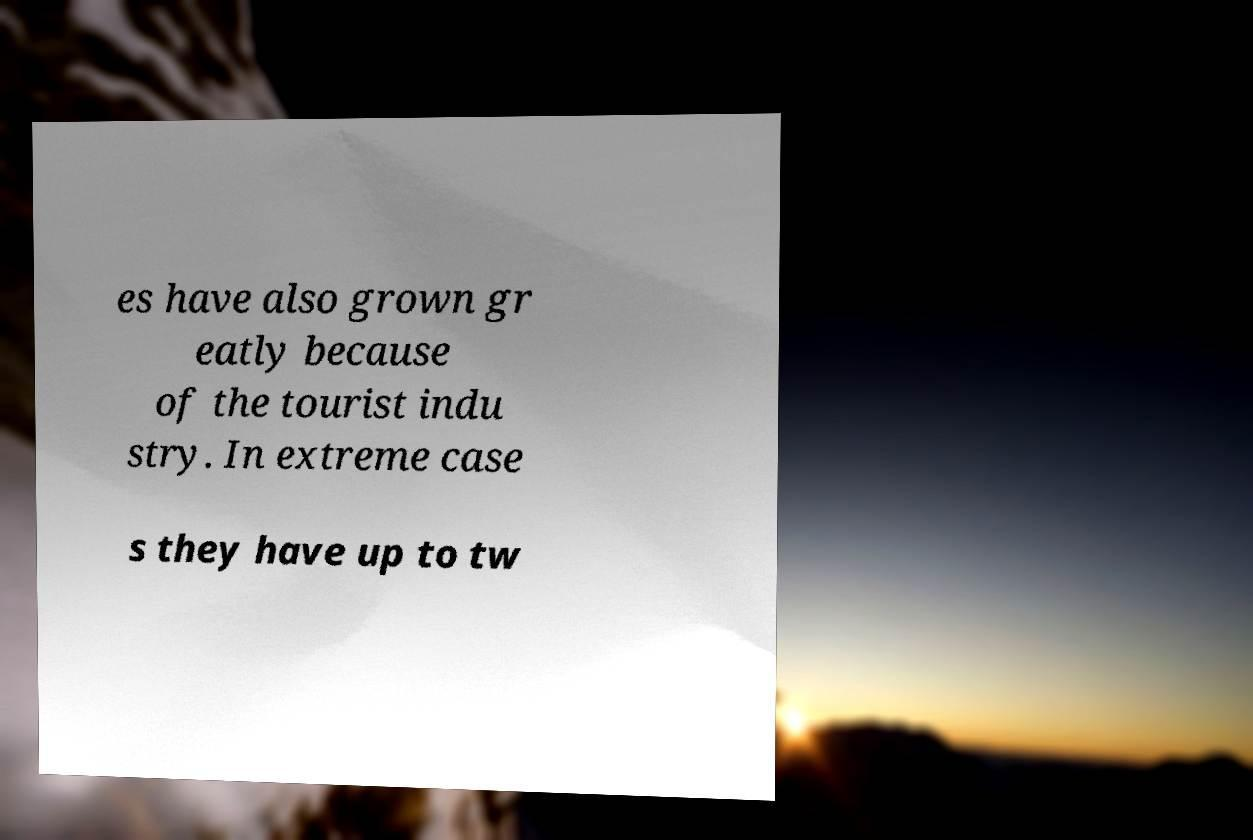Can you read and provide the text displayed in the image?This photo seems to have some interesting text. Can you extract and type it out for me? es have also grown gr eatly because of the tourist indu stry. In extreme case s they have up to tw 